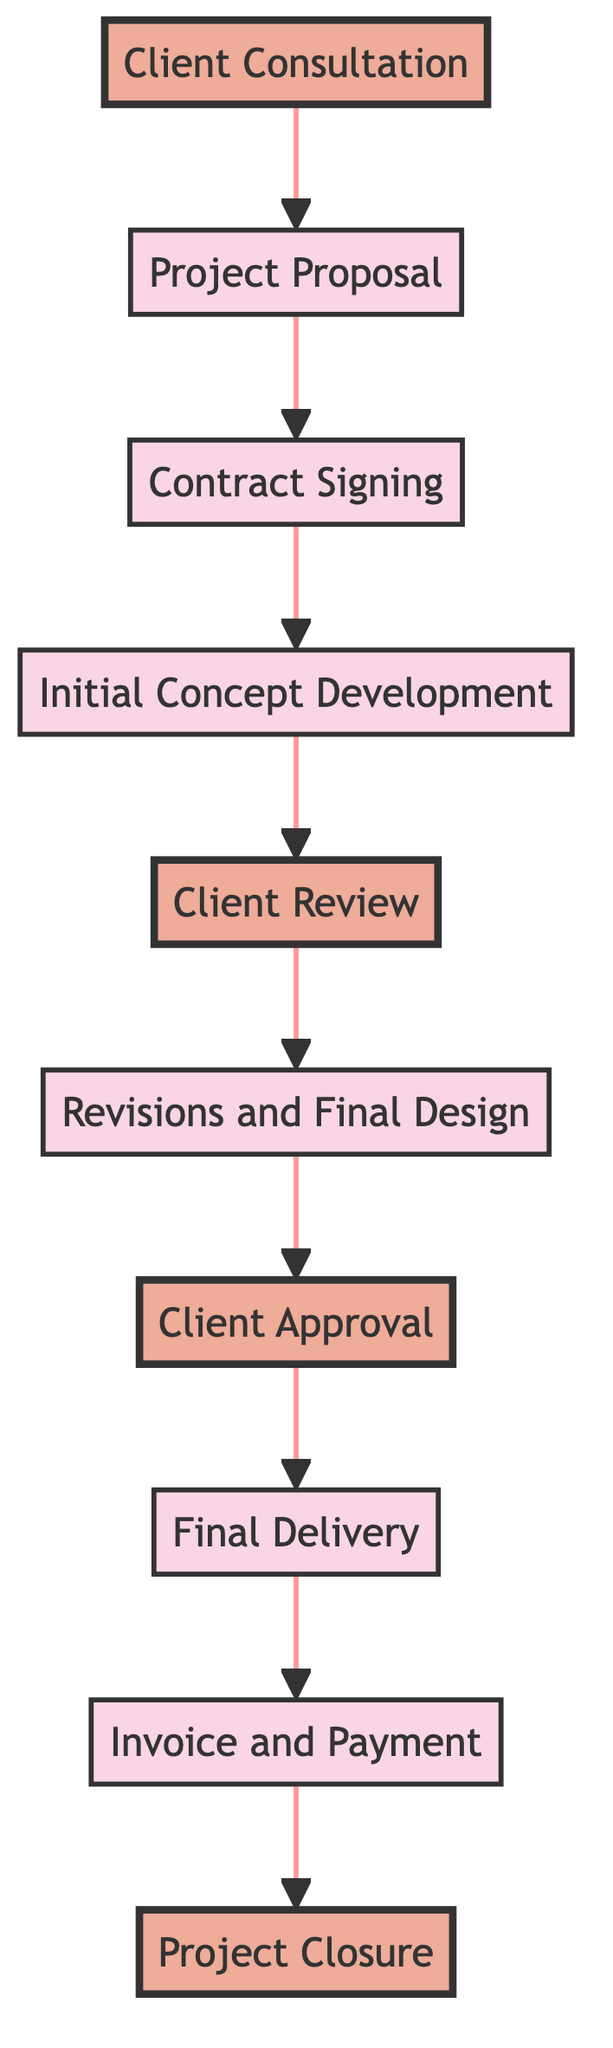What is the first step in the workflow? The first step is "Client Consultation," which is shown as the starting node in the flow chart.
Answer: Client Consultation How many steps are there in total? By counting the nodes in the diagram, there are a total of ten steps from "Client Consultation" to "Project Closure."
Answer: 10 What comes after "Client Review"? The flow chart shows that "Revisions and Final Design" follows after "Client Review."
Answer: Revisions and Final Design Which step involves obtaining feedback? The "Client Review" step is specifically focused on presenting initial concepts to the client and gathering feedback.
Answer: Client Review What are the last two steps in the workflow? The last two steps, as shown in the flow chart, are "Invoice and Payment" followed by "Project Closure."
Answer: Invoice and Payment, Project Closure Which step requires a contract to be signed? The "Contract Signing" step is where a contract outlining terms and conditions is drafted and signed.
Answer: Contract Signing What is the primary purpose of the "Final Delivery" step? The "Final Delivery" step is focused on preparing and delivering the final design files to the client, making it essential for project completion.
Answer: Preparing final files What is the purpose of the "Project Proposal"? The "Project Proposal" outlines the project plan, timeline, deliverables, and cost, which is essential for client approval.
Answer: Outlining project plan How many steps involve client approval? The workflow indicates that there are two steps explicitly related to client approval: "Client Review" and "Client Approval."
Answer: 2 What happens after the "Initial Concept Development"? Following the "Initial Concept Development" step, the next step is "Client Review," which requires presenting the concepts to the client for feedback.
Answer: Client Review 